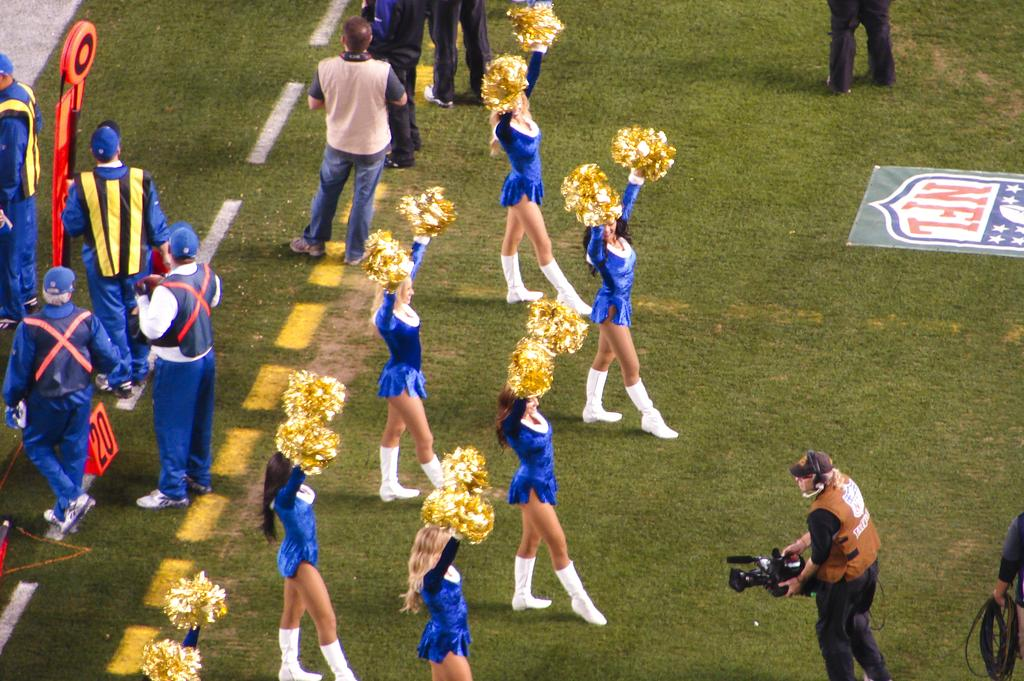<image>
Write a terse but informative summary of the picture. Cheerleaders on a football field with the NFL logo. 